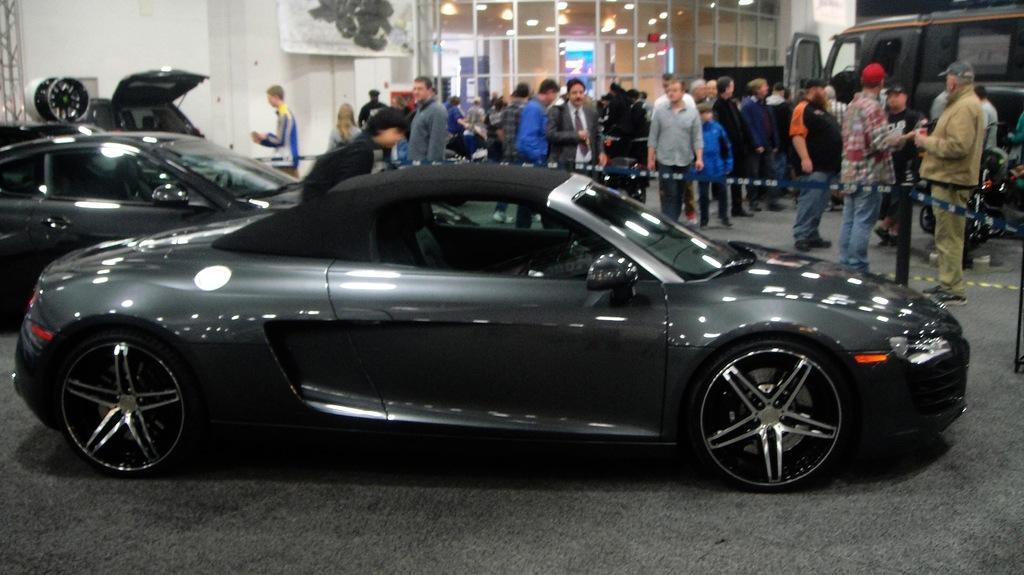Can you describe this image briefly? This picture shows few cars and we see a van on the side and few people standing and cars are black in color. 